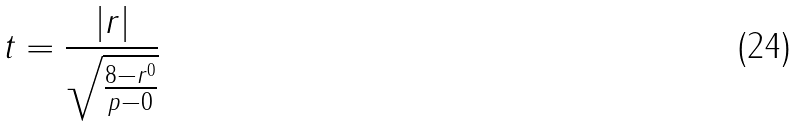<formula> <loc_0><loc_0><loc_500><loc_500>t = \frac { | r | } { \sqrt { \frac { 8 - r ^ { 0 } } { p - 0 } } }</formula> 